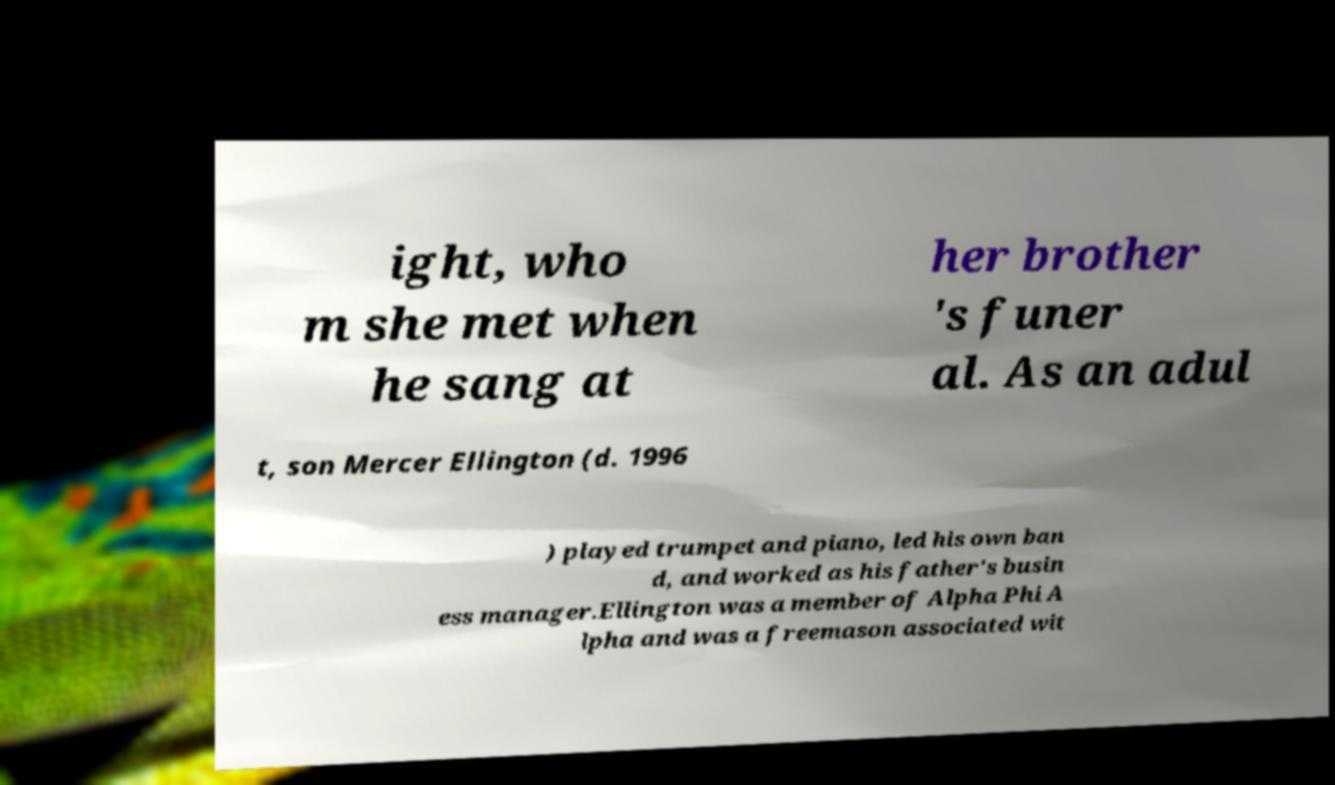Could you extract and type out the text from this image? ight, who m she met when he sang at her brother 's funer al. As an adul t, son Mercer Ellington (d. 1996 ) played trumpet and piano, led his own ban d, and worked as his father's busin ess manager.Ellington was a member of Alpha Phi A lpha and was a freemason associated wit 